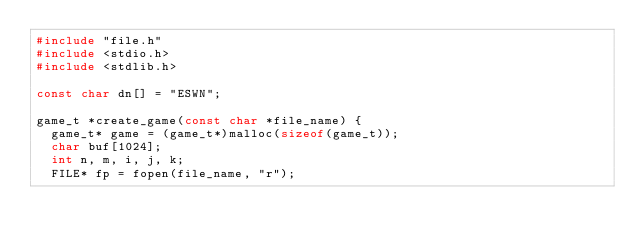<code> <loc_0><loc_0><loc_500><loc_500><_C_>#include "file.h"
#include <stdio.h>
#include <stdlib.h>

const char dn[] = "ESWN";

game_t *create_game(const char *file_name) {
  game_t* game = (game_t*)malloc(sizeof(game_t));
  char buf[1024];
  int n, m, i, j, k;
  FILE* fp = fopen(file_name, "r");</code> 